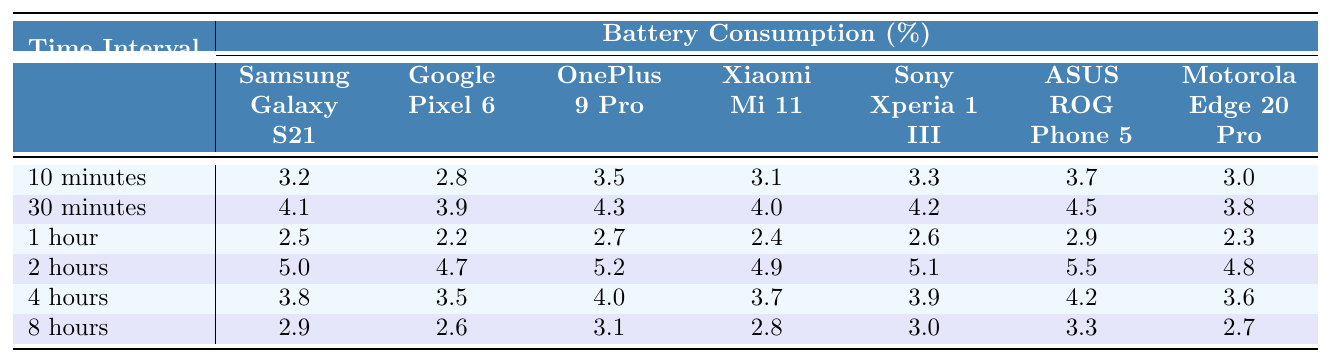What is the battery consumption of the Google Pixel 6 after 1 hour? Looking at the table under the "1 hour" row and the column for "Google Pixel 6", the value is 2.2.
Answer: 2.2 Which device consumed the most battery in 2 hours? In the "2 hours" row, by comparing the values across all devices, the maximum value is 5.5, which corresponds to the "ASUS ROG Phone 5".
Answer: ASUS ROG Phone 5 What is the average battery consumption for the Xiaomi Mi 11 over all time intervals? Adding the consumption values for Xiaomi Mi 11 (5.0 + 4.7 + 5.2 + 4.9 + 3.7 + 2.8 = 26.3) and dividing by the number of intervals (6), we get an average of 26.3 / 6 = 4.38.
Answer: 4.38 Is the battery consumption of Samsung Galaxy S21 higher than the Google Pixel 6 after 30 minutes? Comparing the values in the "30 minutes" row, Samsung Galaxy S21 has 4.1 and Google Pixel 6 has 3.9. Since 4.1 > 3.9, it is true that Samsung Galaxy S21 consumes more.
Answer: Yes What is the difference in battery consumption between the OnePlus 9 Pro and Motorola Edge 20 Pro after 4 hours? In the "4 hours" row, OnePlus 9 Pro's consumption is 4.0 and Motorola Edge 20 Pro's is 3.6. The difference is 4.0 - 3.6 = 0.4.
Answer: 0.4 How much battery does the Sony Xperia 1 III consume over the 8 hour interval compared to the Xiaomi Mi 11? Sony Xperia 1 III consumes 3.0 and Xiaomi Mi 11 consumes 2.8 in the "8 hours" row. Subtracting gives 3.0 - 2.8 = 0.2, so Sony Xperia 1 III consumes more.
Answer: 0.2 Which device has the lowest battery consumption across all time intervals? By reviewing the table for the minimum values, the OnePlus 9 Pro has the lowest maximum value of 2.5 at "1 hour".
Answer: OnePlus 9 Pro What is the maximum battery consumption recorded across any device in the 10 minutes interval? In the "10 minutes" row, the maximum value is found by looking through all devices, which shows that ASUS ROG Phone 5 has the highest at 3.7.
Answer: 3.7 Which device's battery efficiency improves the most from 30 minutes to 8 hours? For 30 minutes, ASUS ROG Phone 5 consumes 4.5 and for 8 hours, it consumes 3.3. The change is 4.5 - 3.3 = 1.2. This is the greatest reduction noted for any device.
Answer: 1.2 What is the sum of battery consumptions for Google Pixel 6 over all measured time intervals? Adding up the values: (4.1 + 3.9 + 2.2 + 4.7 + 3.5 + 2.6) gives 21.0.
Answer: 21.0 